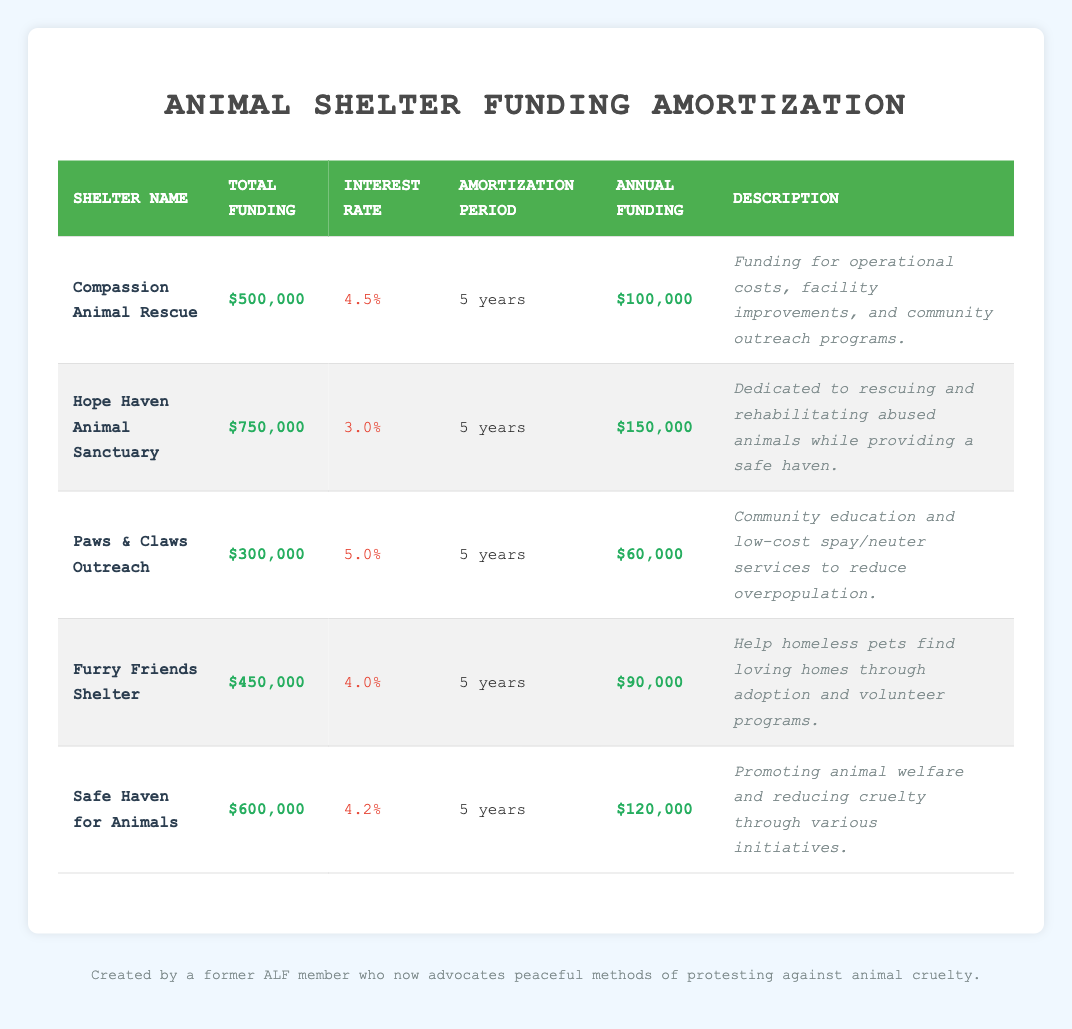What is the total funding for Hope Haven Animal Sanctuary? The table lists "Hope Haven Animal Sanctuary" and shows its total funding as "$750,000."
Answer: $750,000 What is the interest rate for Furry Friends Shelter? The table indicates that Furry Friends Shelter has an interest rate of "4.0%."
Answer: 4.0% Which animal shelter has the highest annual funding? By comparing the annual funding amounts: Compassion Animal Rescue ($100,000), Hope Haven Animal Sanctuary ($150,000), Paws & Claws Outreach ($60,000), Furry Friends Shelter ($90,000), Safe Haven for Animals ($120,000), we find that Hope Haven Animal Sanctuary has the highest annual funding of $150,000.
Answer: Hope Haven Animal Sanctuary What is the average interest rate of all animal shelters listed? To find the average, sum the interest rates: (4.5 + 3.0 + 5.0 + 4.0 + 4.2) = 20.7. There are 5 shelters, so the average is 20.7/5 = 4.14.
Answer: 4.14 Does Safe Haven for Animals have a total funding greater than $500,000? The total funding for Safe Haven for Animals is "$600,000," which is indeed greater than "$500,000."
Answer: Yes Which shelter has the lowest annual funding, and what is that amount? Comparing annual funding amounts, Paws & Claws Outreach has the lowest at "$60,000."
Answer: Paws & Claws Outreach - $60,000 What can you determine about the relationship between total funding and interest rate for the shelters? The table does not show a consistent trend between total funding and interest rate. For example, Hope Haven Animal Sanctuary has the highest funding ($750,000) but a lower interest rate (3.0%). Meanwhile, Paws & Claws Outreach has the lowest funding ($300,000) but the highest interest rate (5.0%). Therefore, total funding and interest rates are not directly correlated for these shelters.
Answer: No consistent relationship What is the total annual funding for all the shelters combined? Adding the annual funding: $100,000 + $150,000 + $60,000 + $90,000 + $120,000 = $520,000. Therefore, the total annual funding amounts to $520,000.
Answer: $520,000 